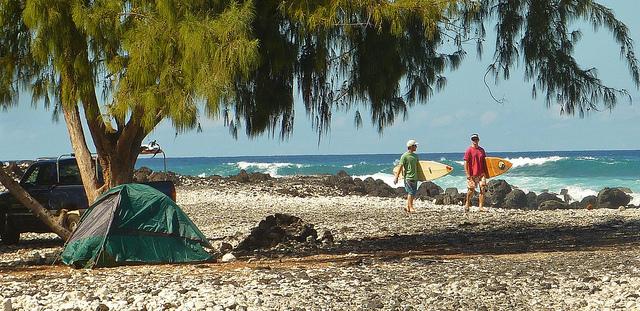Is there a shelter anywhere?
Short answer required. Yes. Why might these people be campers?
Answer briefly. Tent. What are the items under the people's arms?
Short answer required. Surfboards. 